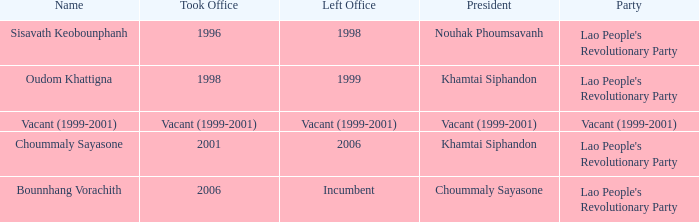What is the departure year, when the inauguration year is 2006? Incumbent. 